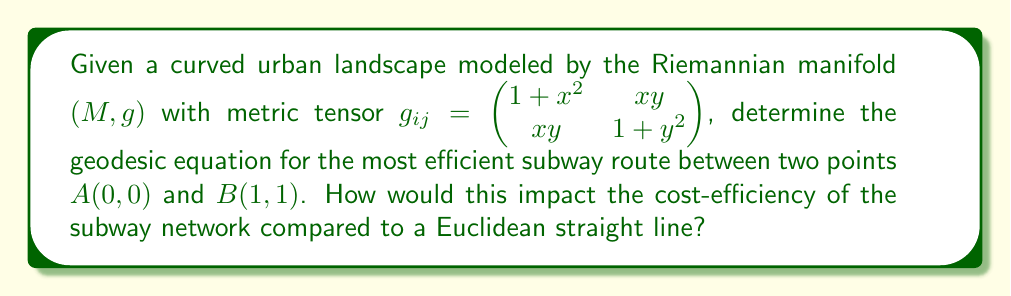Show me your answer to this math problem. To solve this problem, we'll follow these steps:

1) The geodesic equation in general form is:

   $$\frac{d^2x^k}{dt^2} + \Gamma^k_{ij}\frac{dx^i}{dt}\frac{dx^j}{dt} = 0$$

   where $\Gamma^k_{ij}$ are the Christoffel symbols.

2) Calculate the Christoffel symbols using:

   $$\Gamma^k_{ij} = \frac{1}{2}g^{kl}(\partial_i g_{jl} + \partial_j g_{il} - \partial_l g_{ij})$$

3) The inverse metric tensor $g^{ij}$ is:

   $$g^{ij} = \frac{1}{(1+x^2)(1+y^2)-x^2y^2}\begin{pmatrix} 1+y^2 & -xy \\ -xy & 1+x^2 \end{pmatrix}$$

4) Calculating the Christoffel symbols (omitting the details due to space constraints):

   $$\Gamma^1_{11} = \frac{x(1+y^2)}{1+x^2+y^2}, \Gamma^1_{12} = \Gamma^1_{21} = \frac{y}{1+x^2+y^2}$$
   $$\Gamma^1_{22} = -\frac{x}{1+x^2+y^2}, \Gamma^2_{11} = -\frac{y}{1+x^2+y^2}$$
   $$\Gamma^2_{12} = \Gamma^2_{21} = \frac{x}{1+x^2+y^2}, \Gamma^2_{22} = \frac{y(1+x^2)}{1+x^2+y^2}$$

5) Substituting these into the geodesic equation gives us two coupled differential equations:

   $$\frac{d^2x}{dt^2} + \frac{x(1+y^2)}{1+x^2+y^2}\left(\frac{dx}{dt}\right)^2 + \frac{2y}{1+x^2+y^2}\frac{dx}{dt}\frac{dy}{dt} - \frac{x}{1+x^2+y^2}\left(\frac{dy}{dt}\right)^2 = 0$$

   $$\frac{d^2y}{dt^2} - \frac{y}{1+x^2+y^2}\left(\frac{dx}{dt}\right)^2 + \frac{2x}{1+x^2+y^2}\frac{dx}{dt}\frac{dy}{dt} + \frac{y(1+x^2)}{1+x^2+y^2}\left(\frac{dy}{dt}\right)^2 = 0$$

6) These equations describe the geodesic path between A(0,0) and B(1,1).

7) Compared to a Euclidean straight line, this geodesic path would be curved and potentially longer. However, it would follow the natural curvature of the urban landscape, potentially reducing construction costs and improving overall efficiency.

8) The cost-efficiency impact would depend on factors such as:
   - Reduced tunneling costs by following natural contours
   - Potentially longer route increasing operational costs
   - Improved accessibility due to alignment with urban topology

A full cost-benefit analysis would be needed to quantify the exact impact on cost-efficiency.
Answer: Geodesic equations: $$\frac{d^2x}{dt^2} + \frac{x(1+y^2)}{1+x^2+y^2}\left(\frac{dx}{dt}\right)^2 + \frac{2y}{1+x^2+y^2}\frac{dx}{dt}\frac{dy}{dt} - \frac{x}{1+x^2+y^2}\left(\frac{dy}{dt}\right)^2 = 0$$ $$\frac{d^2y}{dt^2} - \frac{y}{1+x^2+y^2}\left(\frac{dx}{dt}\right)^2 + \frac{2x}{1+x^2+y^2}\frac{dx}{dt}\frac{dy}{dt} + \frac{y(1+x^2)}{1+x^2+y^2}\left(\frac{dy}{dt}\right)^2 = 0$$ 